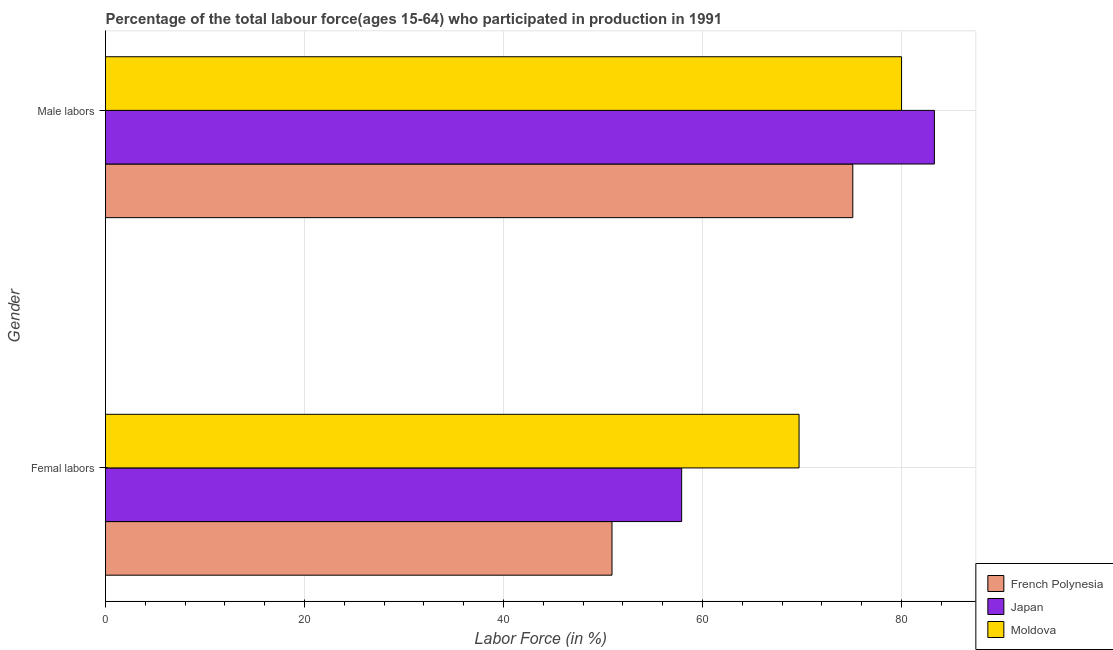How many different coloured bars are there?
Your answer should be very brief. 3. How many groups of bars are there?
Your response must be concise. 2. Are the number of bars per tick equal to the number of legend labels?
Keep it short and to the point. Yes. Are the number of bars on each tick of the Y-axis equal?
Your response must be concise. Yes. How many bars are there on the 2nd tick from the top?
Ensure brevity in your answer.  3. How many bars are there on the 1st tick from the bottom?
Your response must be concise. 3. What is the label of the 1st group of bars from the top?
Provide a succinct answer. Male labors. What is the percentage of female labor force in Japan?
Offer a very short reply. 57.9. Across all countries, what is the maximum percentage of female labor force?
Your answer should be compact. 69.7. Across all countries, what is the minimum percentage of male labour force?
Provide a short and direct response. 75.1. In which country was the percentage of female labor force maximum?
Offer a terse response. Moldova. In which country was the percentage of male labour force minimum?
Your answer should be compact. French Polynesia. What is the total percentage of male labour force in the graph?
Provide a short and direct response. 238.4. What is the difference between the percentage of male labour force in French Polynesia and that in Moldova?
Make the answer very short. -4.9. What is the difference between the percentage of female labor force in French Polynesia and the percentage of male labour force in Japan?
Your answer should be very brief. -32.4. What is the average percentage of female labor force per country?
Make the answer very short. 59.5. What is the difference between the percentage of male labour force and percentage of female labor force in Moldova?
Your response must be concise. 10.3. In how many countries, is the percentage of male labour force greater than 76 %?
Your answer should be very brief. 2. What is the ratio of the percentage of female labor force in Japan to that in French Polynesia?
Your answer should be very brief. 1.14. In how many countries, is the percentage of male labour force greater than the average percentage of male labour force taken over all countries?
Your response must be concise. 2. What does the 2nd bar from the bottom in Femal labors represents?
Make the answer very short. Japan. How many bars are there?
Your answer should be very brief. 6. Are all the bars in the graph horizontal?
Keep it short and to the point. Yes. What is the difference between two consecutive major ticks on the X-axis?
Your answer should be compact. 20. Does the graph contain grids?
Offer a terse response. Yes. Where does the legend appear in the graph?
Make the answer very short. Bottom right. How many legend labels are there?
Keep it short and to the point. 3. What is the title of the graph?
Offer a terse response. Percentage of the total labour force(ages 15-64) who participated in production in 1991. What is the label or title of the X-axis?
Offer a terse response. Labor Force (in %). What is the label or title of the Y-axis?
Give a very brief answer. Gender. What is the Labor Force (in %) in French Polynesia in Femal labors?
Ensure brevity in your answer.  50.9. What is the Labor Force (in %) of Japan in Femal labors?
Offer a very short reply. 57.9. What is the Labor Force (in %) of Moldova in Femal labors?
Keep it short and to the point. 69.7. What is the Labor Force (in %) of French Polynesia in Male labors?
Give a very brief answer. 75.1. What is the Labor Force (in %) of Japan in Male labors?
Your answer should be very brief. 83.3. Across all Gender, what is the maximum Labor Force (in %) of French Polynesia?
Provide a short and direct response. 75.1. Across all Gender, what is the maximum Labor Force (in %) of Japan?
Offer a terse response. 83.3. Across all Gender, what is the maximum Labor Force (in %) of Moldova?
Ensure brevity in your answer.  80. Across all Gender, what is the minimum Labor Force (in %) of French Polynesia?
Provide a succinct answer. 50.9. Across all Gender, what is the minimum Labor Force (in %) of Japan?
Your response must be concise. 57.9. Across all Gender, what is the minimum Labor Force (in %) of Moldova?
Offer a very short reply. 69.7. What is the total Labor Force (in %) of French Polynesia in the graph?
Your response must be concise. 126. What is the total Labor Force (in %) of Japan in the graph?
Provide a succinct answer. 141.2. What is the total Labor Force (in %) in Moldova in the graph?
Provide a short and direct response. 149.7. What is the difference between the Labor Force (in %) of French Polynesia in Femal labors and that in Male labors?
Offer a very short reply. -24.2. What is the difference between the Labor Force (in %) of Japan in Femal labors and that in Male labors?
Ensure brevity in your answer.  -25.4. What is the difference between the Labor Force (in %) of French Polynesia in Femal labors and the Labor Force (in %) of Japan in Male labors?
Provide a short and direct response. -32.4. What is the difference between the Labor Force (in %) in French Polynesia in Femal labors and the Labor Force (in %) in Moldova in Male labors?
Ensure brevity in your answer.  -29.1. What is the difference between the Labor Force (in %) of Japan in Femal labors and the Labor Force (in %) of Moldova in Male labors?
Provide a short and direct response. -22.1. What is the average Labor Force (in %) in French Polynesia per Gender?
Make the answer very short. 63. What is the average Labor Force (in %) of Japan per Gender?
Ensure brevity in your answer.  70.6. What is the average Labor Force (in %) of Moldova per Gender?
Your response must be concise. 74.85. What is the difference between the Labor Force (in %) of French Polynesia and Labor Force (in %) of Japan in Femal labors?
Provide a short and direct response. -7. What is the difference between the Labor Force (in %) of French Polynesia and Labor Force (in %) of Moldova in Femal labors?
Your answer should be very brief. -18.8. What is the difference between the Labor Force (in %) in French Polynesia and Labor Force (in %) in Japan in Male labors?
Offer a very short reply. -8.2. What is the ratio of the Labor Force (in %) in French Polynesia in Femal labors to that in Male labors?
Your response must be concise. 0.68. What is the ratio of the Labor Force (in %) of Japan in Femal labors to that in Male labors?
Make the answer very short. 0.7. What is the ratio of the Labor Force (in %) in Moldova in Femal labors to that in Male labors?
Your answer should be compact. 0.87. What is the difference between the highest and the second highest Labor Force (in %) of French Polynesia?
Make the answer very short. 24.2. What is the difference between the highest and the second highest Labor Force (in %) of Japan?
Offer a terse response. 25.4. What is the difference between the highest and the lowest Labor Force (in %) in French Polynesia?
Keep it short and to the point. 24.2. What is the difference between the highest and the lowest Labor Force (in %) in Japan?
Make the answer very short. 25.4. 